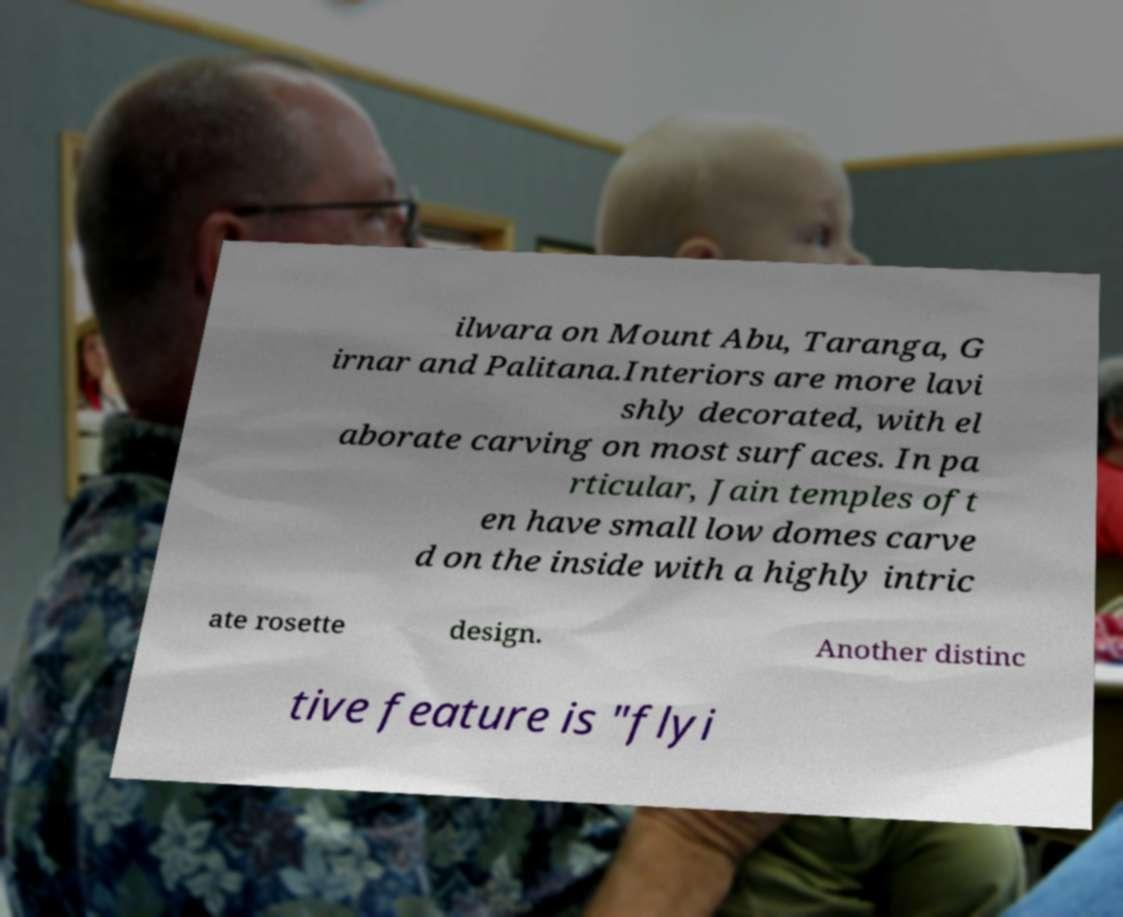Can you read and provide the text displayed in the image?This photo seems to have some interesting text. Can you extract and type it out for me? ilwara on Mount Abu, Taranga, G irnar and Palitana.Interiors are more lavi shly decorated, with el aborate carving on most surfaces. In pa rticular, Jain temples oft en have small low domes carve d on the inside with a highly intric ate rosette design. Another distinc tive feature is "flyi 